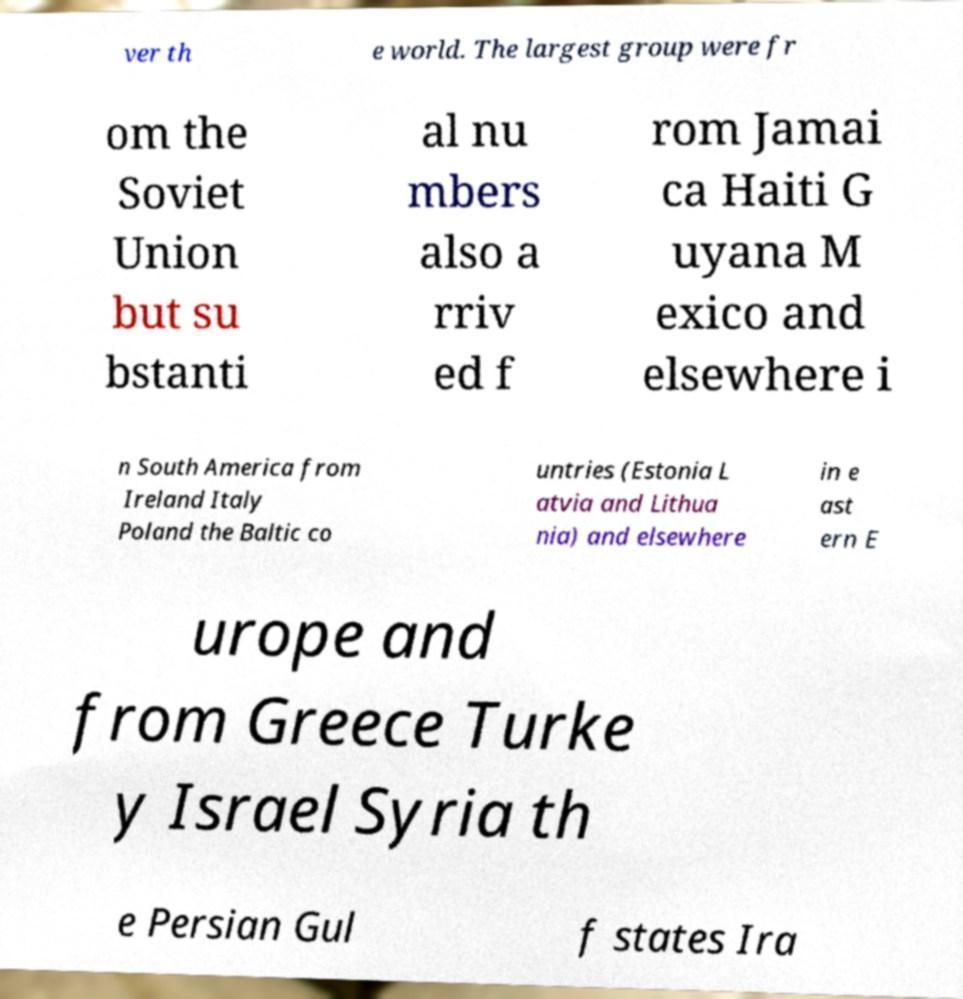There's text embedded in this image that I need extracted. Can you transcribe it verbatim? ver th e world. The largest group were fr om the Soviet Union but su bstanti al nu mbers also a rriv ed f rom Jamai ca Haiti G uyana M exico and elsewhere i n South America from Ireland Italy Poland the Baltic co untries (Estonia L atvia and Lithua nia) and elsewhere in e ast ern E urope and from Greece Turke y Israel Syria th e Persian Gul f states Ira 